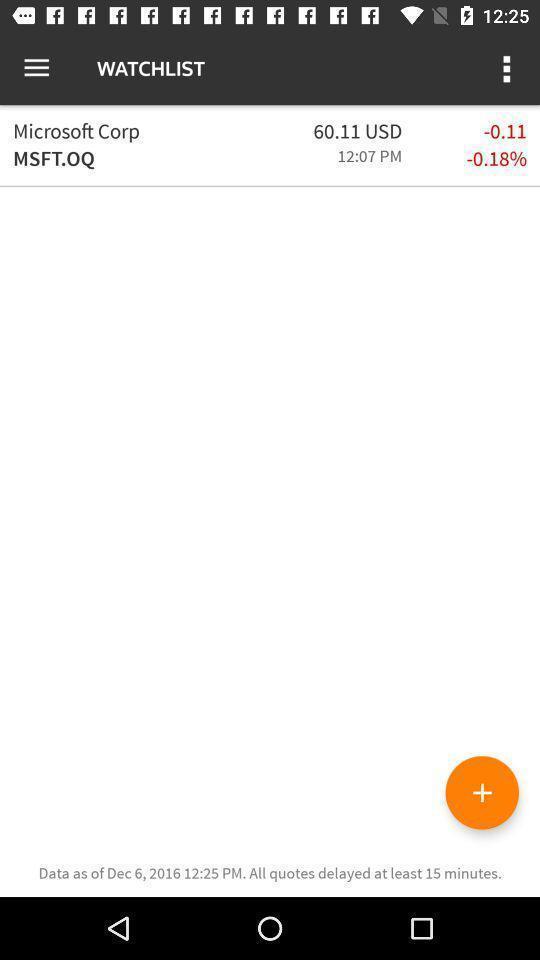Give me a narrative description of this picture. Page showing watch list in app. 